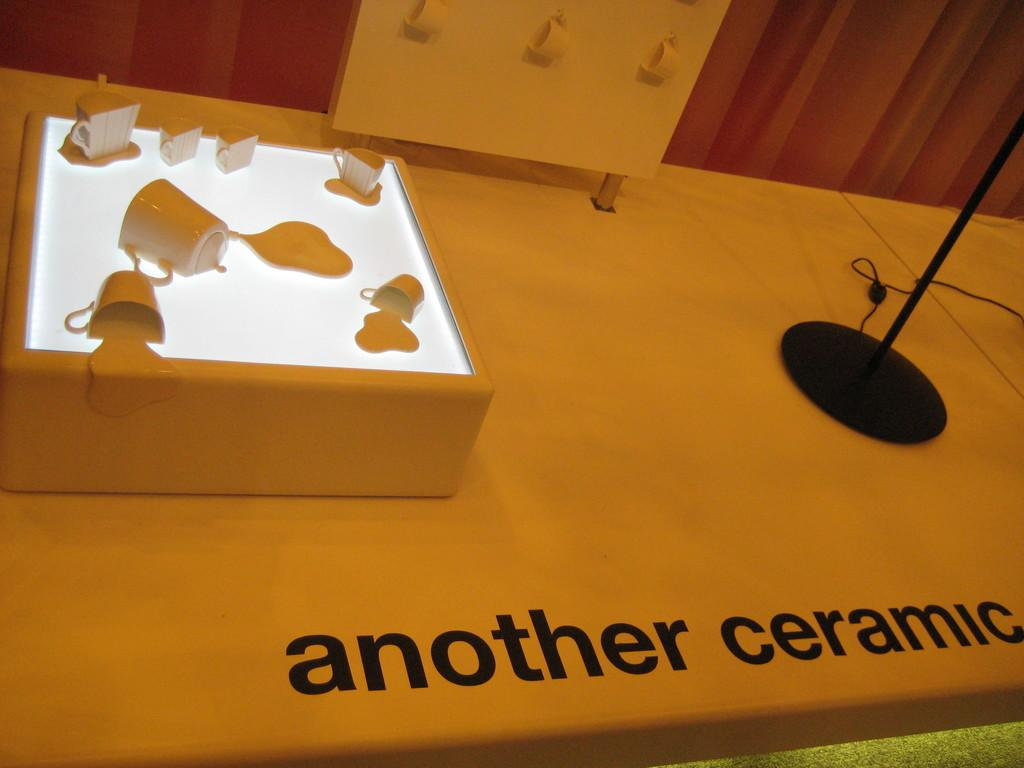Provide a one-sentence caption for the provided image. Ceramic mugs are on display as if they are melting into a light surface. 